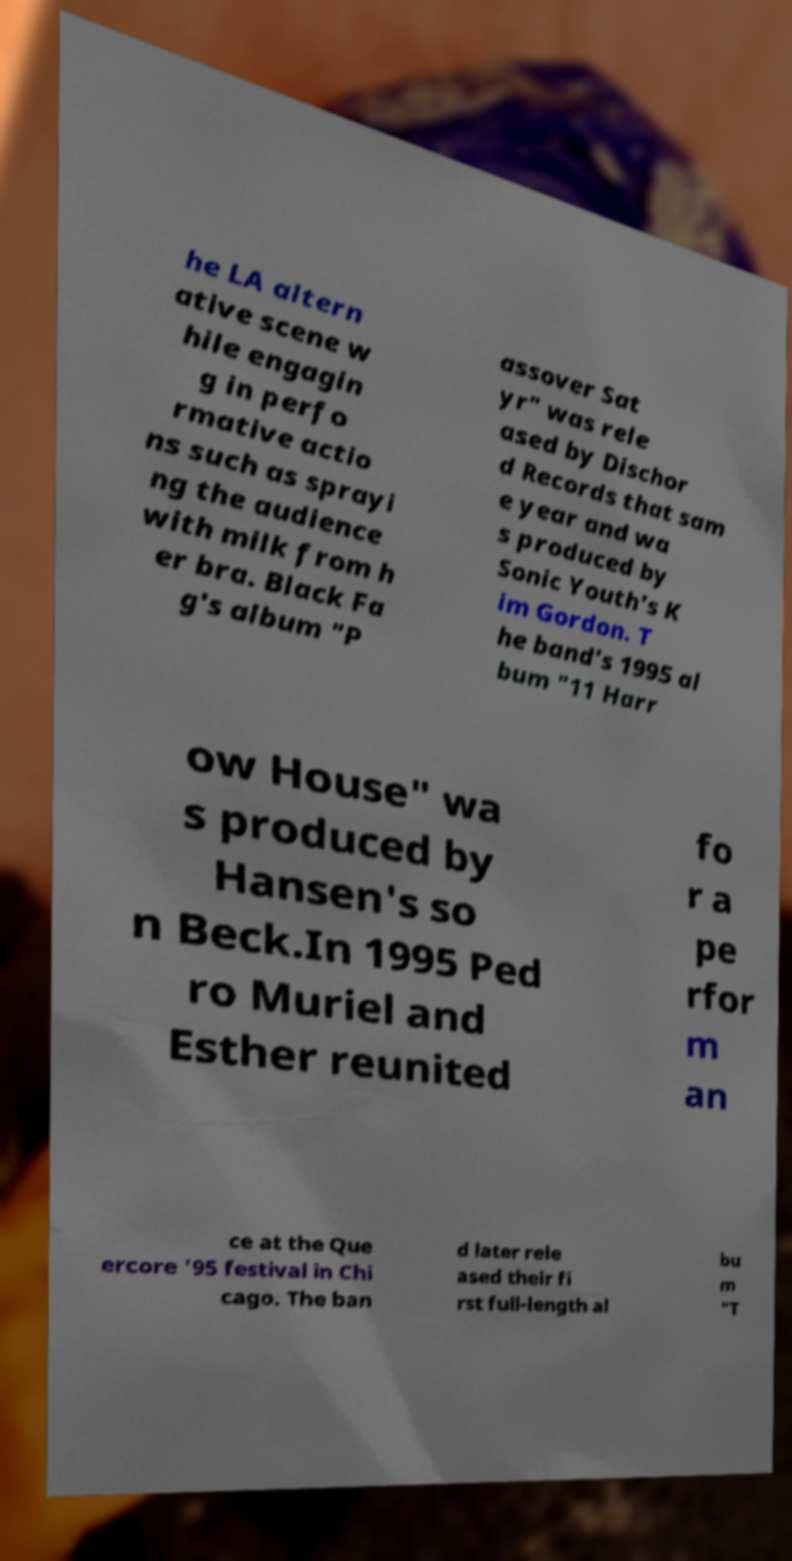Could you assist in decoding the text presented in this image and type it out clearly? he LA altern ative scene w hile engagin g in perfo rmative actio ns such as sprayi ng the audience with milk from h er bra. Black Fa g's album "P assover Sat yr" was rele ased by Dischor d Records that sam e year and wa s produced by Sonic Youth's K im Gordon. T he band's 1995 al bum "11 Harr ow House" wa s produced by Hansen's so n Beck.In 1995 Ped ro Muriel and Esther reunited fo r a pe rfor m an ce at the Que ercore '95 festival in Chi cago. The ban d later rele ased their fi rst full-length al bu m "T 